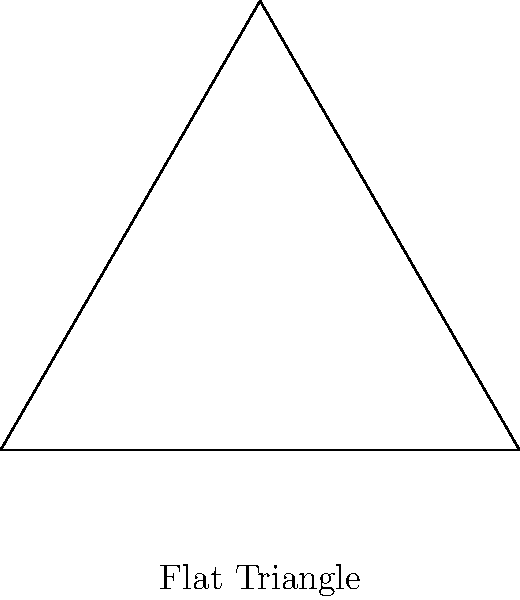As a government official responsible for urban planning, you're tasked with explaining why traditional Euclidean geometry might not always apply in large-scale projects. How does the sum of interior angles in a triangle on a sphere (such as the Earth's surface) differ from that on a flat plane, and why might this be relevant for extensive infrastructure projects? To understand the difference between triangles on a flat plane versus a sphere, let's follow these steps:

1. Flat plane triangle:
   - In Euclidean geometry, the sum of interior angles of a triangle is always $180^\circ$ or $\pi$ radians.
   - This is constant regardless of the triangle's size or shape.

2. Spherical triangle:
   - On a sphere, the sum of interior angles is always greater than $180^\circ$ or $\pi$ radians.
   - The formula for the sum of angles in a spherical triangle is: $\alpha + \beta + \gamma = \pi + A$
     Where $\alpha$, $\beta$, and $\gamma$ are the interior angles, and $A$ is the area of the triangle on the unit sphere.

3. Excess angle:
   - The difference between the sum of angles in a spherical triangle and $180^\circ$ is called the spherical excess.
   - Spherical excess $= (\alpha + \beta + \gamma) - \pi = A$

4. Relevance to large-scale projects:
   - For small areas, the difference is negligible, and Euclidean geometry suffices.
   - For large infrastructure projects covering significant portions of the Earth's surface, this difference becomes noticeable.
   - Ignoring this could lead to accumulated errors in measurements, affecting the accuracy of land surveys, construction plans, and navigation systems.

5. Practical implications:
   - Projects like transcontinental railways, long-distance pipelines, or global positioning systems need to account for the Earth's curvature.
   - Using spherical geometry ensures more accurate calculations for distances, angles, and areas on a large scale.

Understanding this difference is crucial for maintaining the integrity and efficiency of large-scale infrastructure projects, ensuring taxpayer money is used effectively and minimizing potential errors or reconfigurations.
Answer: The sum of interior angles in a spherical triangle is greater than $180^\circ$, unlike $180^\circ$ for a flat triangle, which is crucial for accuracy in large-scale infrastructure projects. 